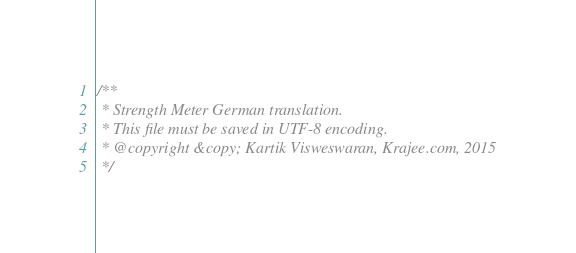Convert code to text. <code><loc_0><loc_0><loc_500><loc_500><_JavaScript_>/**
 * Strength Meter German translation.
 * This file must be saved in UTF-8 encoding.
 * @copyright &copy; Kartik Visweswaran, Krajee.com, 2015
 */</code> 